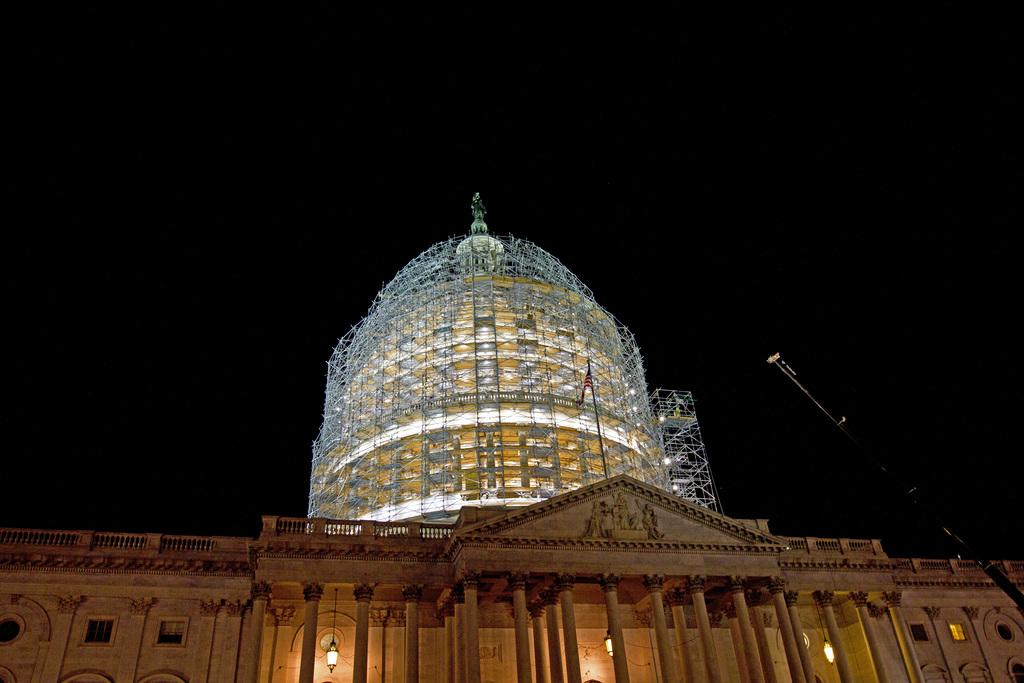What type of structure is located at the bottom of the image? There is a building in the bottom of the image. What can be seen in the middle of the image? There is a tower in the middle of the image. What is visible in the background of the image? The sky is visible in the background of the image. Is there a war happening in the image? There is no indication of a war in the image; it features a building, a tower, and the sky. What type of power source is visible in the image? There is no power source visible in the image; it only shows a building, a tower, and the sky. 